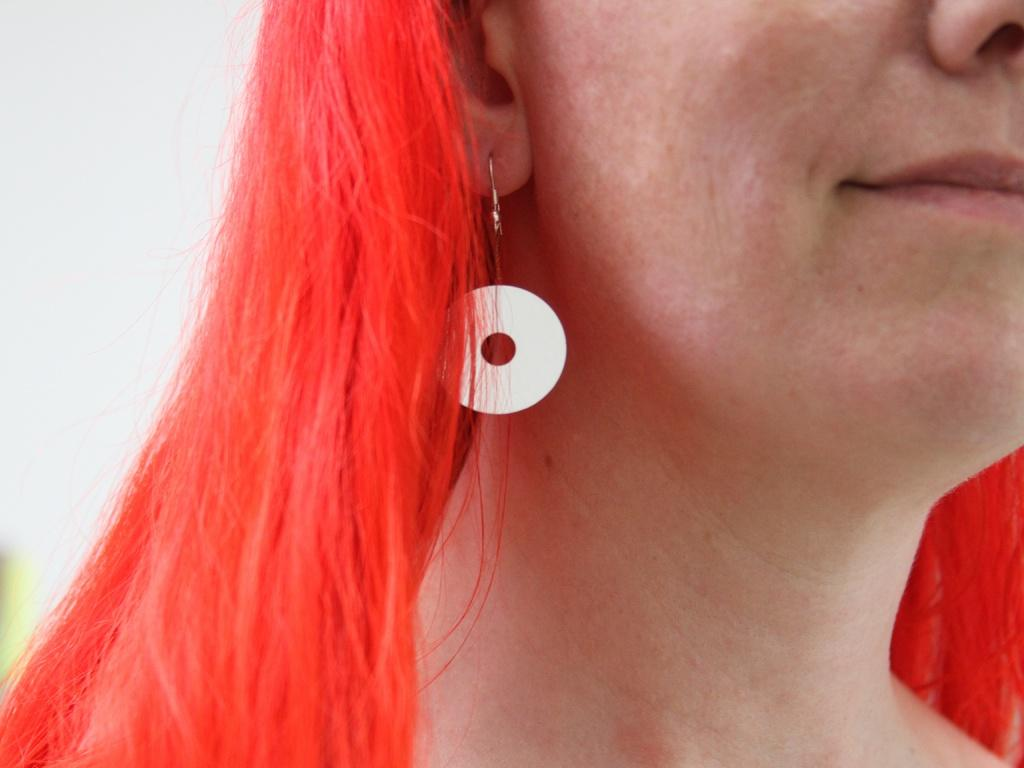Who is the main subject in the image? There is a woman in the image. What is the woman wearing in the image? The woman is wearing an earring. Can you describe the woman's hair color in the image? The woman has orange-colored hair. What is the color of the background in the image? The background of the image is white in color. Does the woman have a tail in the image? No, the woman does not have a tail in the image. Is the woman waving at someone in the image? There is no indication in the image that the woman is waving at someone. 